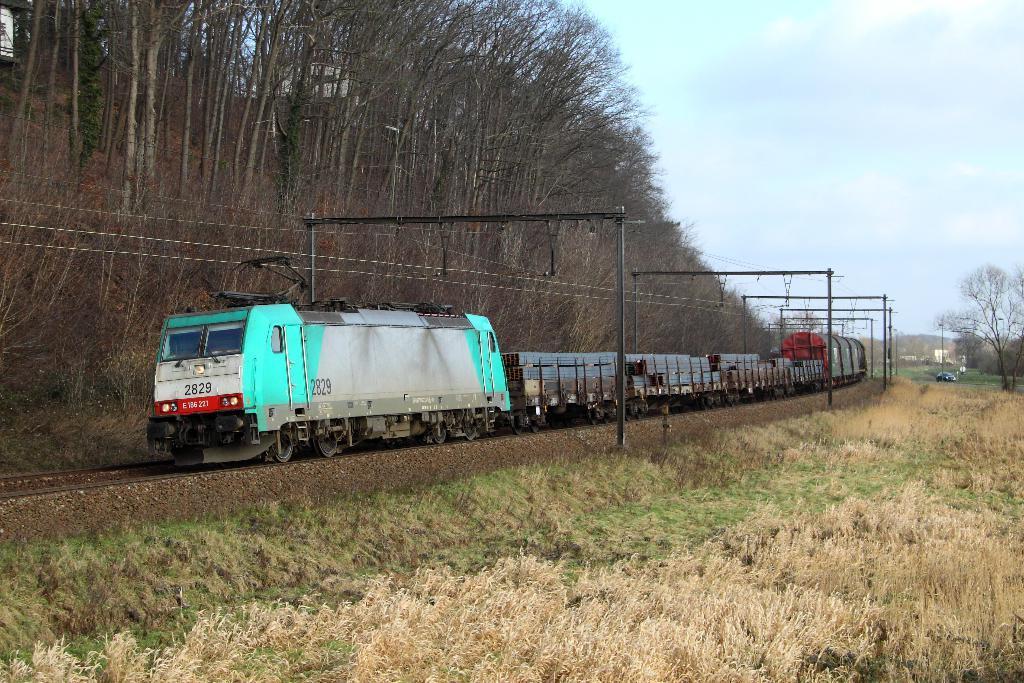Please provide a concise description of this image. This image consists of a tree. At the bottom, there is a track. To the right, there is dry grass on the ground. To the left, there are trees. In the middle, there are poles to which wires are fixed. At the top, there are clouds in the sky. 